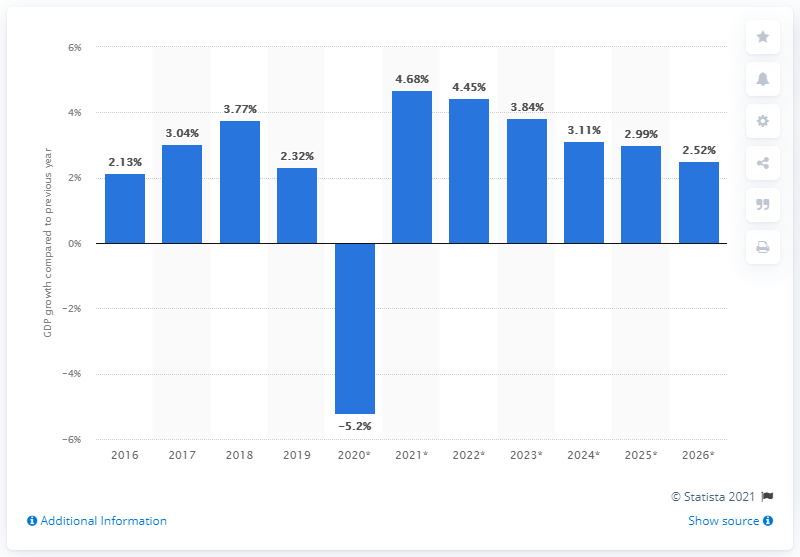Specify some key components in this picture. In 2019, Slovakia's gross domestic product grew by 2.32%. 